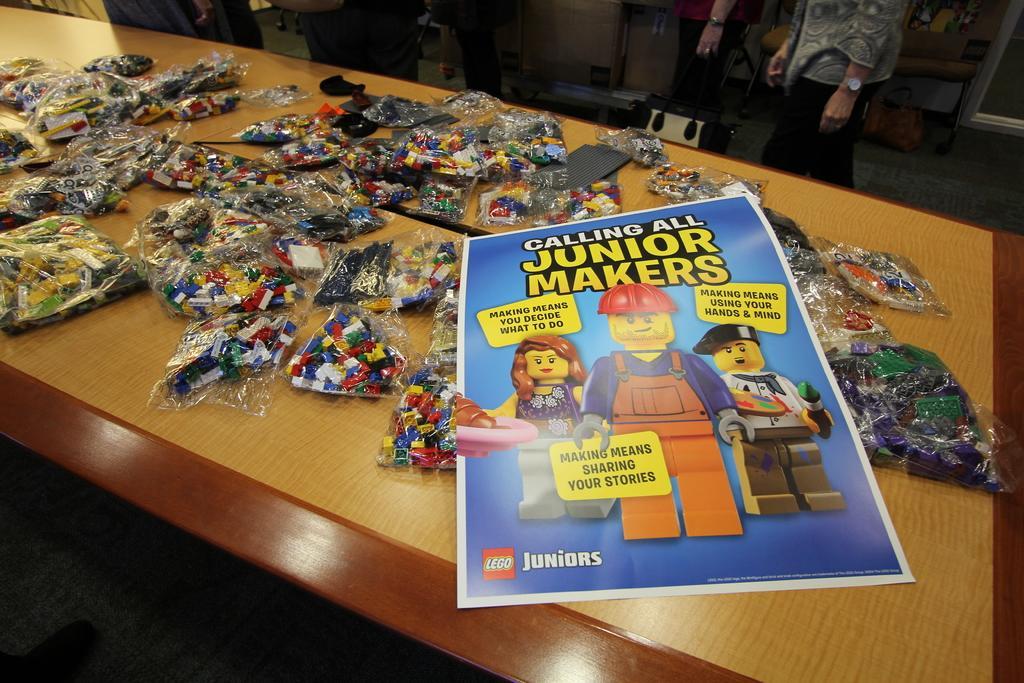Could you give a brief overview of what you see in this image? As we can see in the image there is a table and a person over here. On table there is a poster and building boxes. 